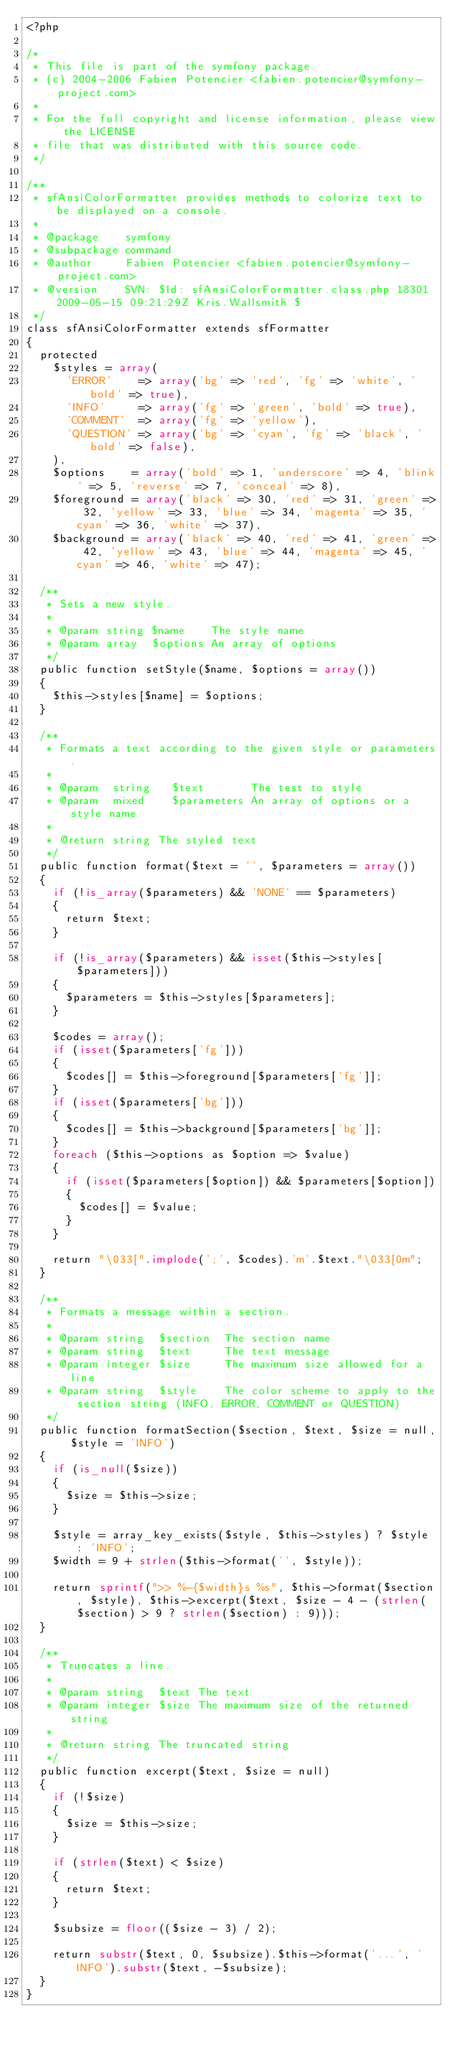<code> <loc_0><loc_0><loc_500><loc_500><_PHP_><?php

/*
 * This file is part of the symfony package.
 * (c) 2004-2006 Fabien Potencier <fabien.potencier@symfony-project.com>
 *
 * For the full copyright and license information, please view the LICENSE
 * file that was distributed with this source code.
 */

/**
 * sfAnsiColorFormatter provides methods to colorize text to be displayed on a console.
 *
 * @package    symfony
 * @subpackage command
 * @author     Fabien Potencier <fabien.potencier@symfony-project.com>
 * @version    SVN: $Id: sfAnsiColorFormatter.class.php 18301 2009-05-15 09:21:29Z Kris.Wallsmith $
 */
class sfAnsiColorFormatter extends sfFormatter
{
  protected
    $styles = array(
      'ERROR'    => array('bg' => 'red', 'fg' => 'white', 'bold' => true),
      'INFO'     => array('fg' => 'green', 'bold' => true),
      'COMMENT'  => array('fg' => 'yellow'),
      'QUESTION' => array('bg' => 'cyan', 'fg' => 'black', 'bold' => false),
    ),
    $options    = array('bold' => 1, 'underscore' => 4, 'blink' => 5, 'reverse' => 7, 'conceal' => 8),
    $foreground = array('black' => 30, 'red' => 31, 'green' => 32, 'yellow' => 33, 'blue' => 34, 'magenta' => 35, 'cyan' => 36, 'white' => 37),
    $background = array('black' => 40, 'red' => 41, 'green' => 42, 'yellow' => 43, 'blue' => 44, 'magenta' => 45, 'cyan' => 46, 'white' => 47);

  /**
   * Sets a new style.
   *
   * @param string $name    The style name
   * @param array  $options An array of options
   */
  public function setStyle($name, $options = array())
  {
    $this->styles[$name] = $options;
  }

  /**
   * Formats a text according to the given style or parameters.
   *
   * @param  string   $text       The test to style
   * @param  mixed    $parameters An array of options or a style name
   *
   * @return string The styled text
   */
  public function format($text = '', $parameters = array())
  {
    if (!is_array($parameters) && 'NONE' == $parameters)
    {
      return $text;
    }

    if (!is_array($parameters) && isset($this->styles[$parameters]))
    {
      $parameters = $this->styles[$parameters];
    }

    $codes = array();
    if (isset($parameters['fg']))
    {
      $codes[] = $this->foreground[$parameters['fg']];
    }
    if (isset($parameters['bg']))
    {
      $codes[] = $this->background[$parameters['bg']];
    }
    foreach ($this->options as $option => $value)
    {
      if (isset($parameters[$option]) && $parameters[$option])
      {
        $codes[] = $value;
      }
    }

    return "\033[".implode(';', $codes).'m'.$text."\033[0m";
  }

  /**
   * Formats a message within a section.
   *
   * @param string  $section  The section name
   * @param string  $text     The text message
   * @param integer $size     The maximum size allowed for a line
   * @param string  $style    The color scheme to apply to the section string (INFO, ERROR, COMMENT or QUESTION)
   */
  public function formatSection($section, $text, $size = null, $style = 'INFO')
  {
    if (is_null($size))
    {
      $size = $this->size;
    }

    $style = array_key_exists($style, $this->styles) ? $style : 'INFO';
    $width = 9 + strlen($this->format('', $style));

    return sprintf(">> %-{$width}s %s", $this->format($section, $style), $this->excerpt($text, $size - 4 - (strlen($section) > 9 ? strlen($section) : 9)));
  }

  /**
   * Truncates a line.
   *
   * @param string  $text The text
   * @param integer $size The maximum size of the returned string
   *
   * @return string The truncated string
   */
  public function excerpt($text, $size = null)
  {
    if (!$size)
    {
      $size = $this->size;
    }

    if (strlen($text) < $size)
    {
      return $text;
    }

    $subsize = floor(($size - 3) / 2);

    return substr($text, 0, $subsize).$this->format('...', 'INFO').substr($text, -$subsize);
  }
}
</code> 